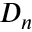<formula> <loc_0><loc_0><loc_500><loc_500>D _ { n }</formula> 